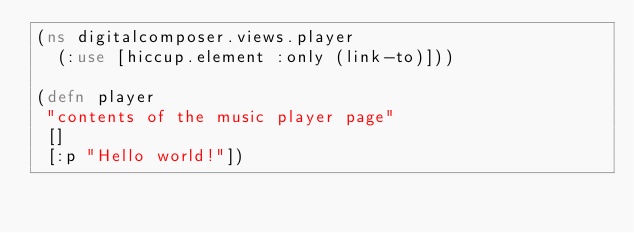<code> <loc_0><loc_0><loc_500><loc_500><_Clojure_>(ns digitalcomposer.views.player
  (:use [hiccup.element :only (link-to)]))

(defn player
 "contents of the music player page"
 []
 [:p "Hello world!"])
</code> 